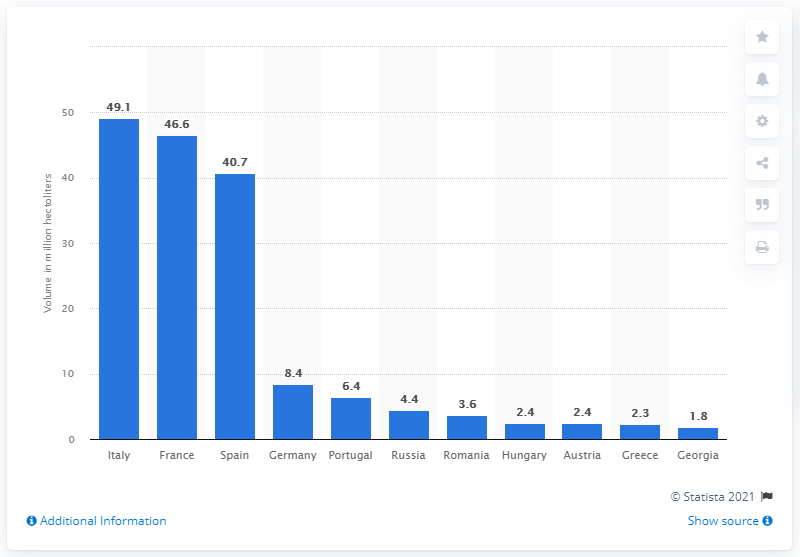Highlight a few significant elements in this photo. In 2020, Italy's wine output was 49.1 million hectoliters. In 2020, Spain was the country in Europe that produced the most wine. The country that produced 46.6 million hectoliters of wine in 2020 was France. 